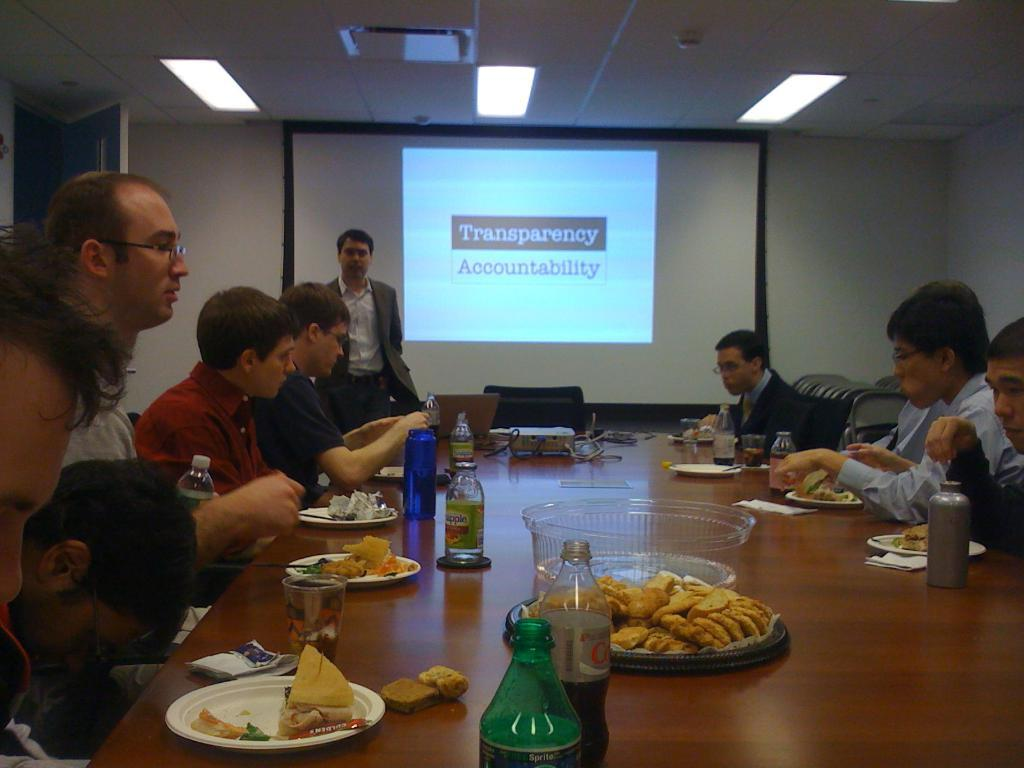What are the people in the image doing? There is a group of people seated in the image. Is there anyone standing in the image? Yes, there is a man standing in the image. What is the purpose of the projector screen in the image? The projector screen is likely used for presentations or visual aids. What can be found on the table in the image? There are food items, bottles, plates, and glasses on the table in the image. How many bikes are parked next to the table in the image? There are no bikes present in the image. What type of silk is draped over the projector screen in the image? There is no silk present in the image; only the projector screen is visible. 